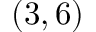<formula> <loc_0><loc_0><loc_500><loc_500>( 3 , 6 )</formula> 